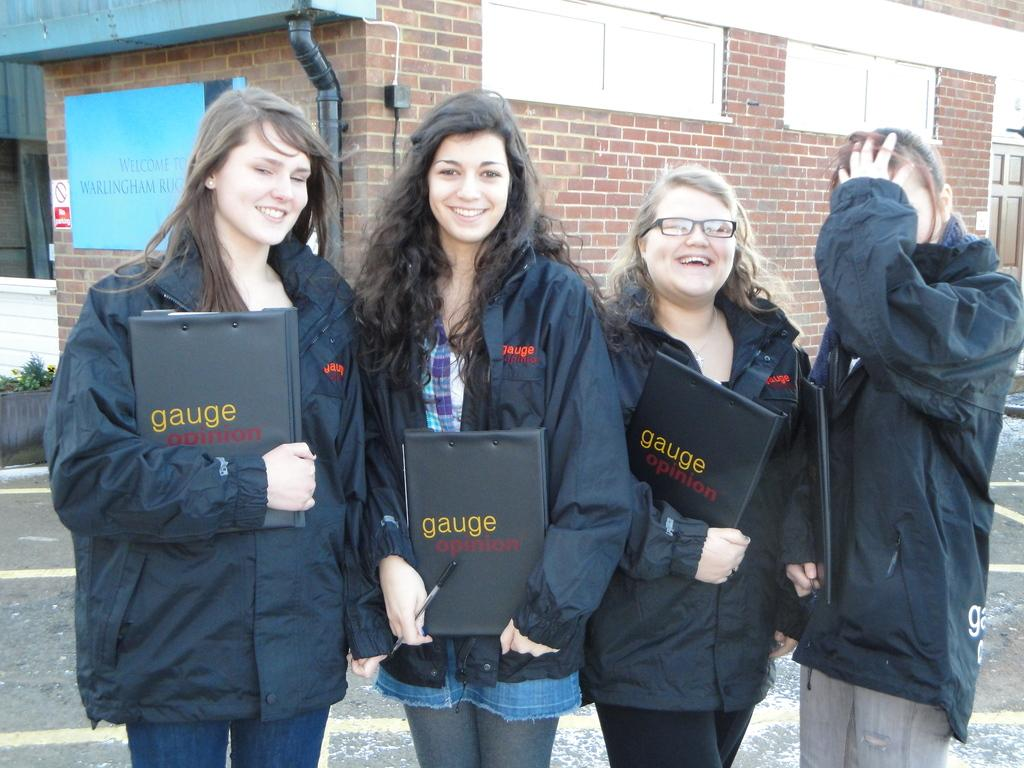How many women are in the image? There are four women in the image. What are the women doing in the image? The women are standing together and holding files. What is the facial expression of most of the women? Three of the women are smiling. What can be seen in the background of the image? There is a house and a door beside the house in the background. What month is it in the image? The image does not provide any information about the month or time of year. How many quinces are visible in the image? There are no quinces present in the image. 